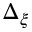Convert formula to latex. <formula><loc_0><loc_0><loc_500><loc_500>\Delta _ { \xi }</formula> 